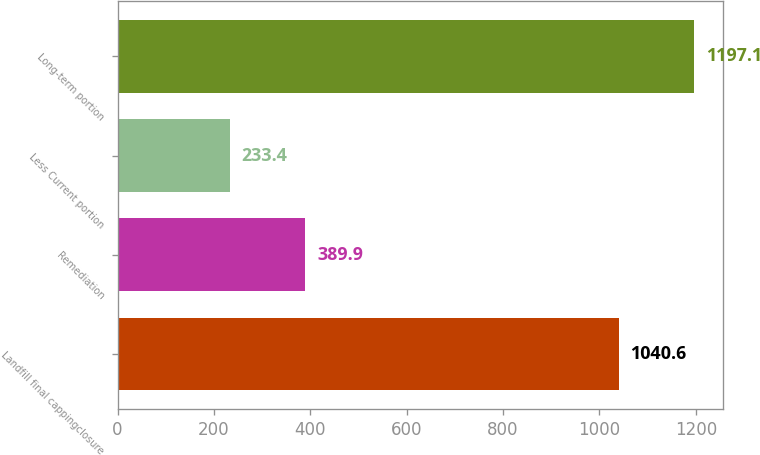Convert chart to OTSL. <chart><loc_0><loc_0><loc_500><loc_500><bar_chart><fcel>Landfill final cappingclosure<fcel>Remediation<fcel>Less Current portion<fcel>Long-term portion<nl><fcel>1040.6<fcel>389.9<fcel>233.4<fcel>1197.1<nl></chart> 